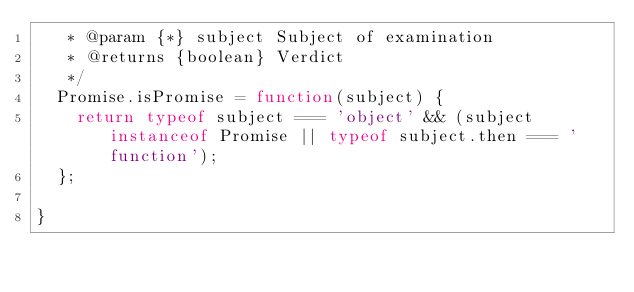Convert code to text. <code><loc_0><loc_0><loc_500><loc_500><_JavaScript_>   * @param {*} subject Subject of examination
   * @returns {boolean} Verdict
   */
  Promise.isPromise = function(subject) {
    return typeof subject === 'object' && (subject instanceof Promise || typeof subject.then === 'function');
  };

}
</code> 